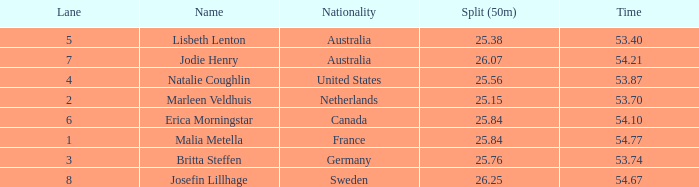What is the slowest 50m split time for a total of 53.74 in a lane of less than 3? None. 